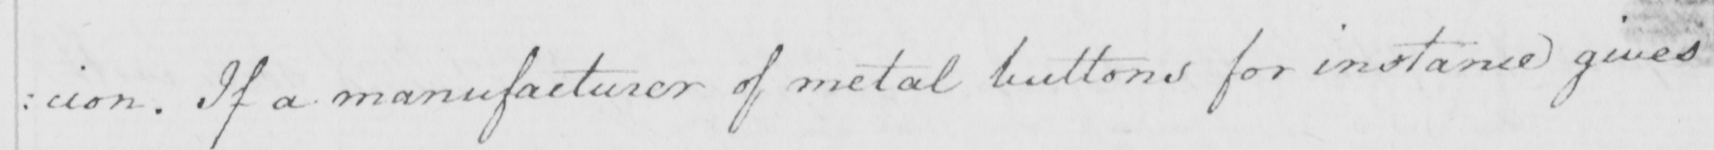Can you tell me what this handwritten text says? : cion . If a manufacturer of metal buttons for instance gives 